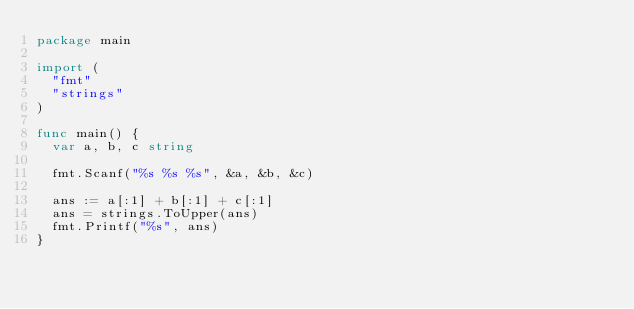Convert code to text. <code><loc_0><loc_0><loc_500><loc_500><_Go_>package main

import (
  "fmt"
  "strings"
)

func main() {
  var a, b, c string
  
  fmt.Scanf("%s %s %s", &a, &b, &c)
  
  ans := a[:1] + b[:1] + c[:1]
  ans = strings.ToUpper(ans)
  fmt.Printf("%s", ans)
}</code> 